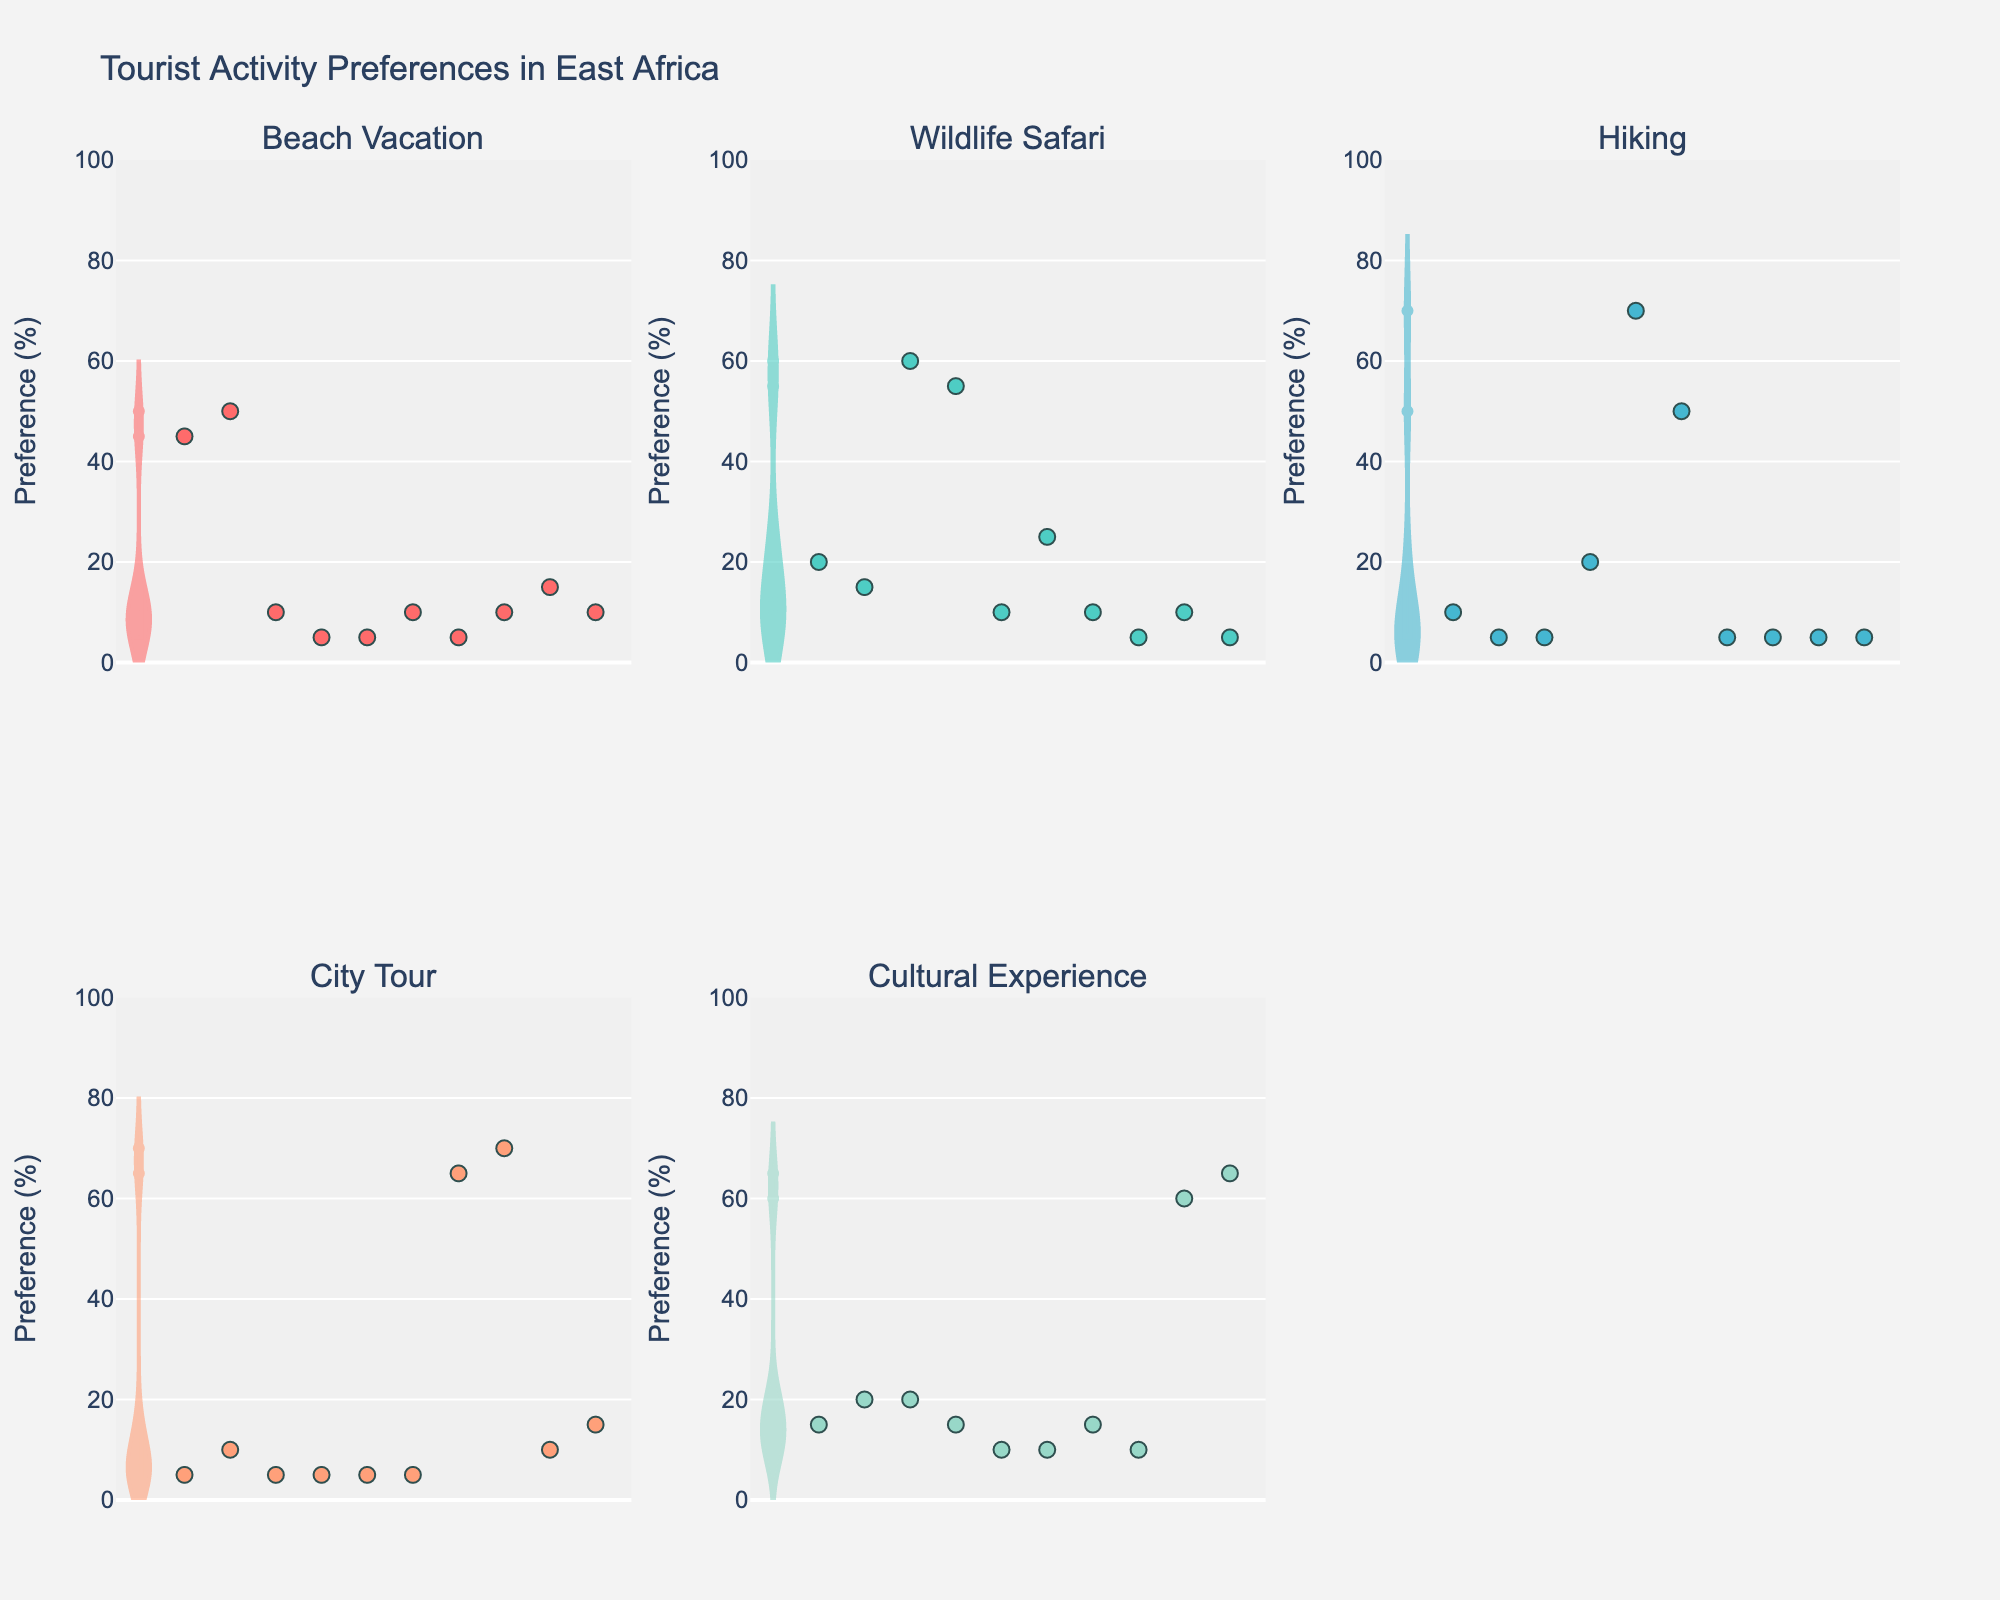What is the title of the figure? The title is prominently displayed at the top of the figure and usually summarizes the main topic of the visualization.
Answer: Tourist Activity Preferences in East Africa Which activity has the highest preference in the 'Wildlife Safari' category? By examining the violin plot for the 'Wildlife Safari' category, look for the tallest or most pronounced peak. This will correspond to the highest preference value.
Answer: Elephant Safari How do preferences for ‘Beach Vacation’ and 'Hiking' compare for Snorkeling? Identify the values for Snorkeling in both 'Beach Vacation' and 'Hiking'. Comparing the two values will provide the answer. Snorkeling has a value of 45 for Beach Vacation and 10 for Hiking.
Answer: Beach Vacation has higher preference Which category exhibits the widest spread of preferences? Analyze the width of the violin plot for each category. The category with the widest plot represents the one with the most significant variability in preferences.
Answer: Beach Vacation What is the most preferred activity for 'Cultural Experience'? Look for the highest value in the 'Cultural Experience' violin plot. Verify this by checking the corresponding activity name.
Answer: Traditional Music Identify the category with the most uniform preferences across activities. Observe the violin plots and compare the uniformity or narrowness of the distributions. The category with the least variation (narrowest plot) is the answer.
Answer: City Tour Which activity has the lowest preference for ‘City Tour’? Check the values for all activities in the 'City Tour' category and find the lowest value.
Answer: Snorkeling and Bird Watching In the 'Local Cuisine' category, how many activities have a preference of 10% or lower? Identify and count the values in the 'Local Cuisine' category that are 10% or lower by examining the violin plot and scatter points. There are three: Museums, Whale Watching, and Snorkeling.
Answer: Three activities Does the preference for Bird Watching in ‘Wildlife Safari’ exceed 50%? Check the value for Bird Watching under the 'Wildlife Safari' category; verify if it is more than 50%.
Answer: Yes Which category has a preference of 70% for an activity associated with nature? Look through the categories and their respective activities. Specifically, find the category with a value of 70% for an activity linked to nature.
Answer: Hiking for Historical Sites 